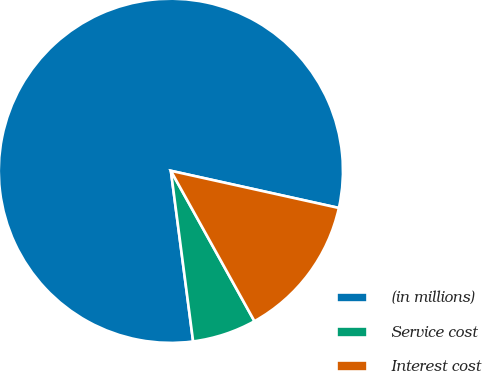<chart> <loc_0><loc_0><loc_500><loc_500><pie_chart><fcel>(in millions)<fcel>Service cost<fcel>Interest cost<nl><fcel>80.53%<fcel>6.01%<fcel>13.46%<nl></chart> 